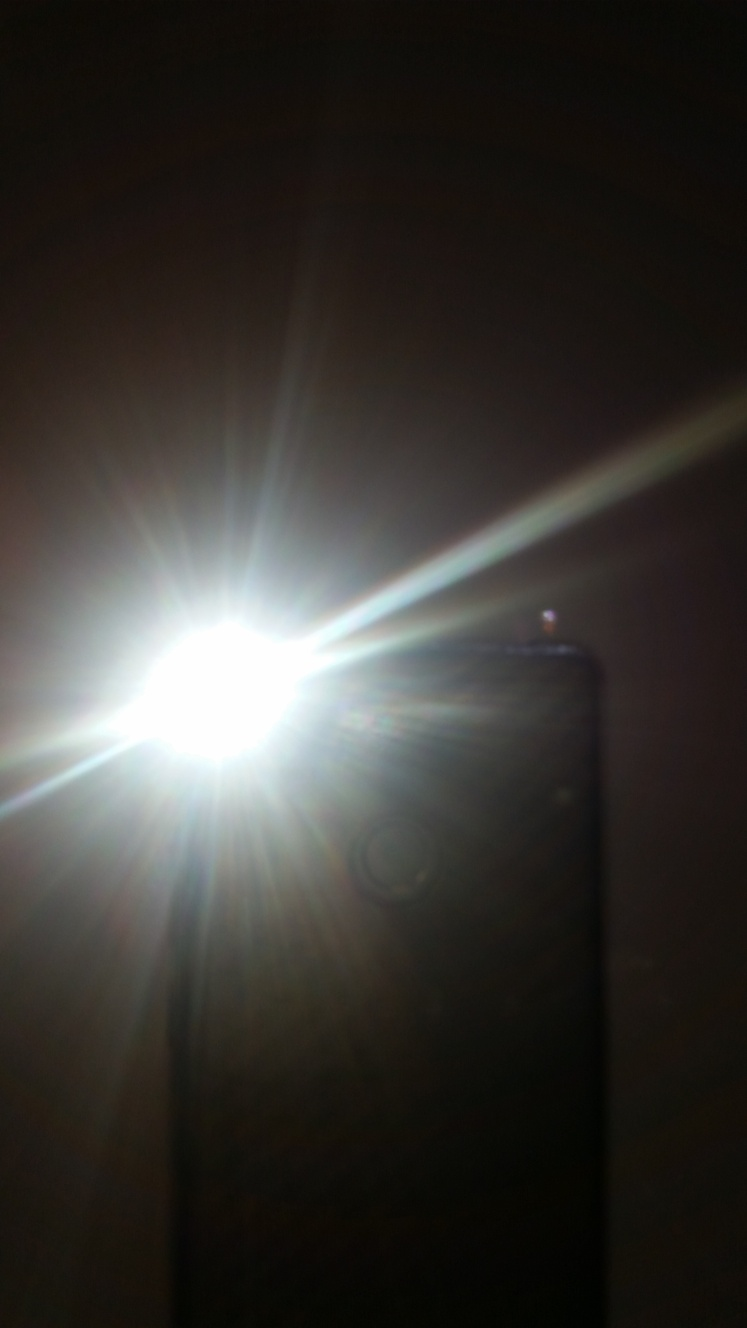What makes it difficult to discern the subject?
A. Good lighting
B. Severe overexposure
C. Sharp focus
D. Underexposure
Answer with the option's letter from the given choices directly.
 B. 